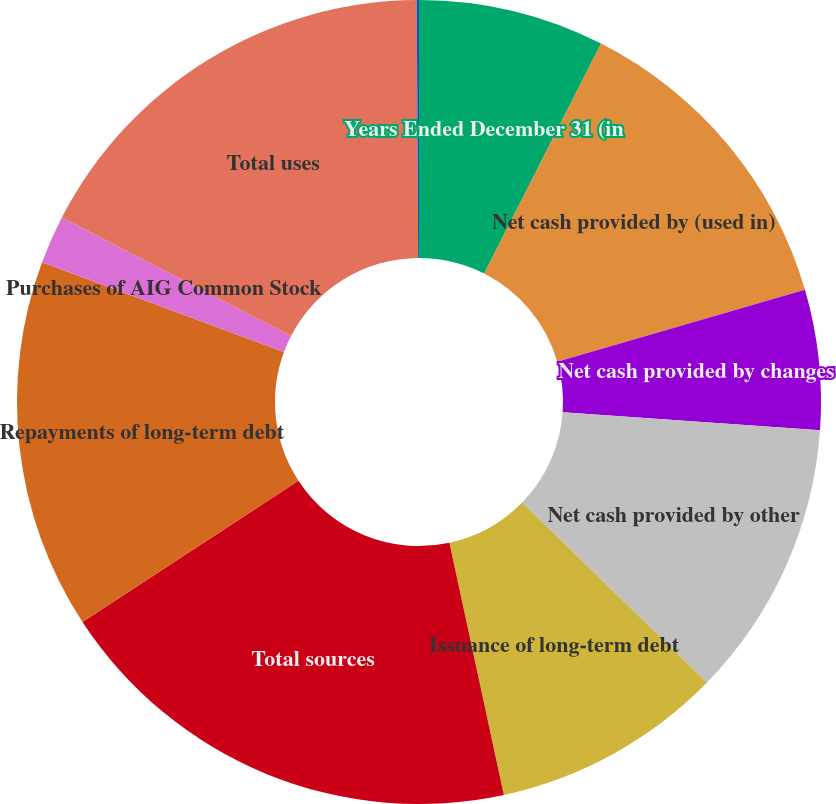Convert chart to OTSL. <chart><loc_0><loc_0><loc_500><loc_500><pie_chart><fcel>Years Ended December 31 (in<fcel>Net cash provided by (used in)<fcel>Net cash provided by changes<fcel>Net cash provided by other<fcel>Issuance of long-term debt<fcel>Total sources<fcel>Repayments of long-term debt<fcel>Purchases of AIG Common Stock<fcel>Total uses<fcel>Effect of exchange rate<nl><fcel>7.48%<fcel>13.01%<fcel>5.63%<fcel>11.17%<fcel>9.32%<fcel>19.17%<fcel>14.86%<fcel>1.94%<fcel>17.32%<fcel>0.09%<nl></chart> 